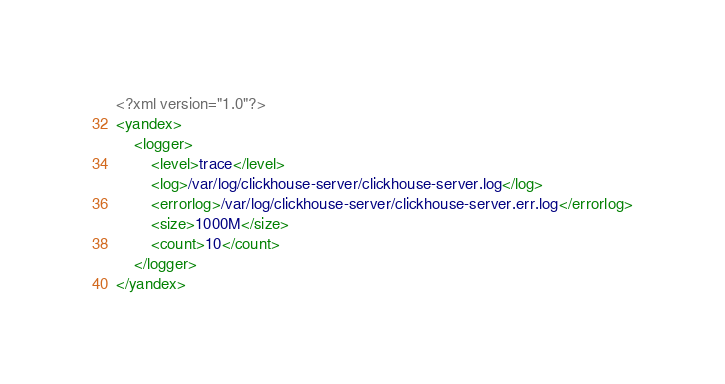<code> <loc_0><loc_0><loc_500><loc_500><_XML_><?xml version="1.0"?>
<yandex>
    <logger>
        <level>trace</level>
        <log>/var/log/clickhouse-server/clickhouse-server.log</log>
        <errorlog>/var/log/clickhouse-server/clickhouse-server.err.log</errorlog>
        <size>1000M</size>
        <count>10</count>
    </logger>
</yandex>
</code> 